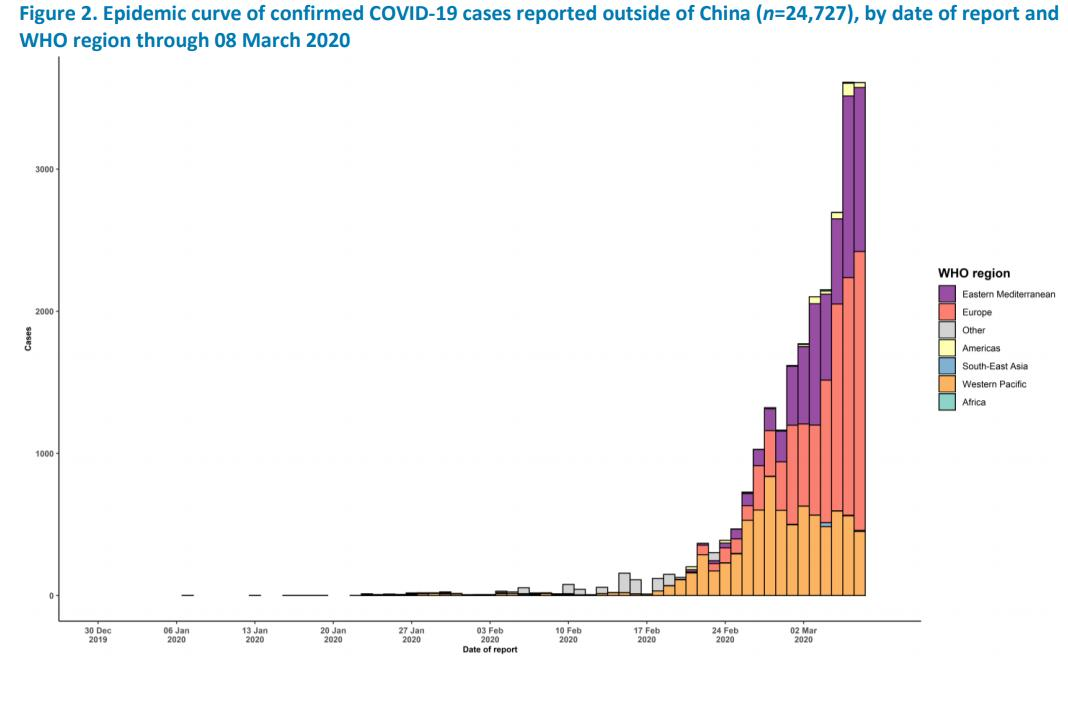Draw attention to some important aspects in this diagram. It is violet that is used to represent Eastern Mediterranean. The color used to represent Western Pacific is orange. 